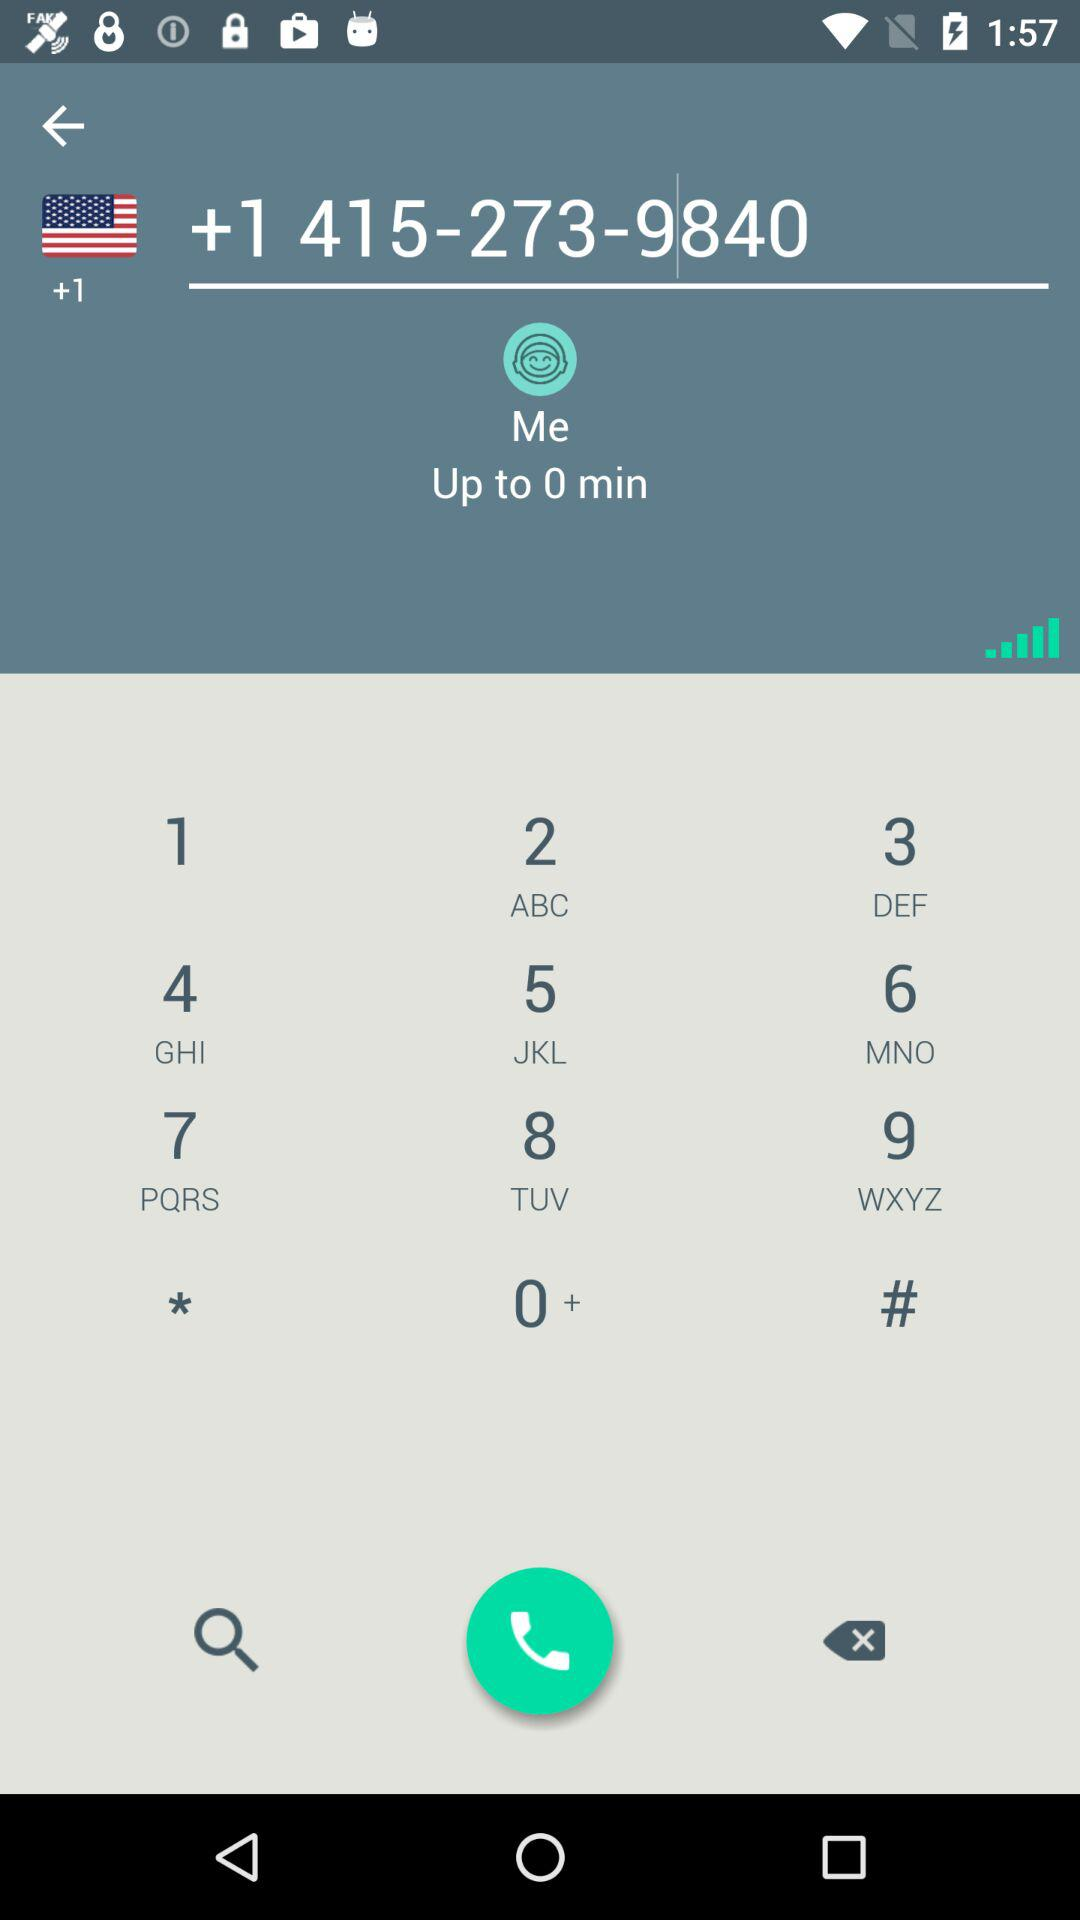What is the contact number? The contact number is +14152739840. 